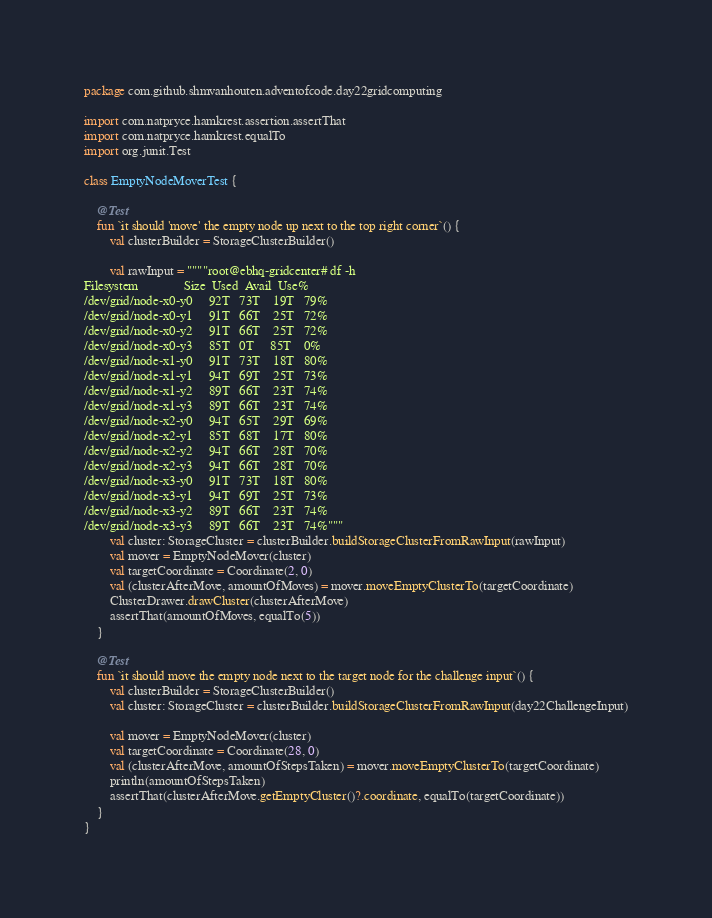<code> <loc_0><loc_0><loc_500><loc_500><_Kotlin_>package com.github.shmvanhouten.adventofcode.day22gridcomputing

import com.natpryce.hamkrest.assertion.assertThat
import com.natpryce.hamkrest.equalTo
import org.junit.Test

class EmptyNodeMoverTest {

    @Test
    fun `it should 'move' the empty node up next to the top right corner`() {
        val clusterBuilder = StorageClusterBuilder()

        val rawInput = """"root@ebhq-gridcenter# df -h
Filesystem              Size  Used  Avail  Use%
/dev/grid/node-x0-y0     92T   73T    19T   79%
/dev/grid/node-x0-y1     91T   66T    25T   72%
/dev/grid/node-x0-y2     91T   66T    25T   72%
/dev/grid/node-x0-y3     85T   0T     85T    0%
/dev/grid/node-x1-y0     91T   73T    18T   80%
/dev/grid/node-x1-y1     94T   69T    25T   73%
/dev/grid/node-x1-y2     89T   66T    23T   74%
/dev/grid/node-x1-y3     89T   66T    23T   74%
/dev/grid/node-x2-y0     94T   65T    29T   69%
/dev/grid/node-x2-y1     85T   68T    17T   80%
/dev/grid/node-x2-y2     94T   66T    28T   70%
/dev/grid/node-x2-y3     94T   66T    28T   70%
/dev/grid/node-x3-y0     91T   73T    18T   80%
/dev/grid/node-x3-y1     94T   69T    25T   73%
/dev/grid/node-x3-y2     89T   66T    23T   74%
/dev/grid/node-x3-y3     89T   66T    23T   74%"""
        val cluster: StorageCluster = clusterBuilder.buildStorageClusterFromRawInput(rawInput)
        val mover = EmptyNodeMover(cluster)
        val targetCoordinate = Coordinate(2, 0)
        val (clusterAfterMove, amountOfMoves) = mover.moveEmptyClusterTo(targetCoordinate)
        ClusterDrawer.drawCluster(clusterAfterMove)
        assertThat(amountOfMoves, equalTo(5))
    }

    @Test
    fun `it should move the empty node next to the target node for the challenge input`() {
        val clusterBuilder = StorageClusterBuilder()
        val cluster: StorageCluster = clusterBuilder.buildStorageClusterFromRawInput(day22ChallengeInput)

        val mover = EmptyNodeMover(cluster)
        val targetCoordinate = Coordinate(28, 0)
        val (clusterAfterMove, amountOfStepsTaken) = mover.moveEmptyClusterTo(targetCoordinate)
        println(amountOfStepsTaken)
        assertThat(clusterAfterMove.getEmptyCluster()?.coordinate, equalTo(targetCoordinate))
    }
}</code> 